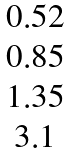Convert formula to latex. <formula><loc_0><loc_0><loc_500><loc_500>\begin{matrix} 0 . 5 2 \\ 0 . 8 5 \\ 1 . 3 5 \\ 3 . 1 \end{matrix}</formula> 